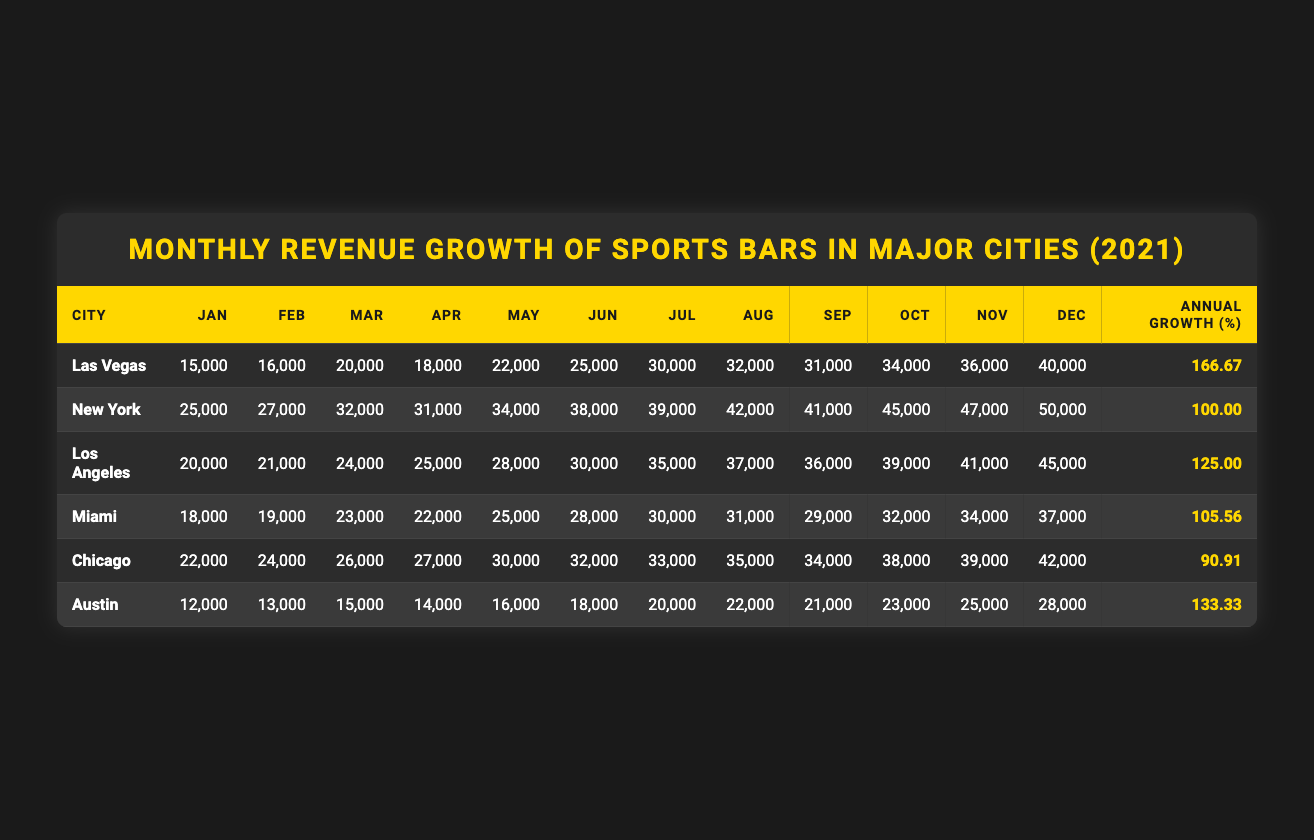What city had the highest monthly revenue in December? Looking at the December values, Las Vegas had 40,000, New York had 50,000, Los Angeles had 45,000, Miami had 37,000, Chicago had 42,000, and Austin had 28,000. New York's value is the highest at 50,000.
Answer: New York Which city experienced the lowest annual growth percentage? The annual growth percentages for each city are: Las Vegas 166.67, New York 100.00, Los Angeles 125.00, Miami 105.56, Chicago 90.91, and Austin 133.33. Chicago has the lowest growth percentage at 90.91.
Answer: Chicago What is the total revenue for Miami in the first half of the year (January to June)? The January to June revenues for Miami are: 18,000 (Jan) + 19,000 (Feb) + 23,000 (Mar) + 22,000 (Apr) + 25,000 (May) + 28,000 (Jun). Adding these values gives 18,000 + 19,000 + 23,000 + 22,000 + 25,000 + 28,000 = 135,000.
Answer: 135,000 In which month did Las Vegas see the revenue exceed 30,000 for the first time? Checking the monthly values for Las Vegas: January 15,000, February 16,000, March 20,000, April 18,000, May 22,000, June 25,000, July 30,000, and August 32,000. The first month exceeding 30,000 is August.
Answer: August What was the average monthly revenue for Los Angeles in 2021? For Los Angeles, the monthly revenues are: 20,000, 21,000, 24,000, 25,000, 28,000, 30,000, 35,000, 37,000, 36,000, 39,000, 41,000, and 45,000. The sum is 20,000 + 21,000 + 24,000 + 25,000 + 28,000 + 30,000 + 35,000 + 37,000 + 36,000 + 39,000 + 41,000 + 45,000 =  408,000. Dividing by 12 gives 408,000 / 12 = 34,000.
Answer: 34,000 Which city had a growth percentage of over 150%? The annual growth percentages are: Las Vegas 166.67, New York 100.00, Los Angeles 125.00, Miami 105.56, Chicago 90.91, and Austin 133.33. Only Las Vegas exceeds 150%.
Answer: Las Vegas If you combined the revenues of Chicago and Austin in October, how much would that be? Chicago's October revenue is 38,000 and Austin's is 23,000. Adding these values gives 38,000 + 23,000 = 61,000.
Answer: 61,000 How many cities showed an annual growth percentage greater than 100%? The cities with growth percentages are: Las Vegas 166.67, New York 100.00, Los Angeles 125.00, Miami 105.56, Chicago 90.91, and Austin 133.33. The cities exceeding 100% are Las Vegas, Los Angeles, Miami, and Austin, totaling four cities.
Answer: Four cities What was the revenue for NYC in March? New York's revenue in March is listed as 32,000 in the table.
Answer: 32,000 In the comparison between Miami and Las Vegas in July, who had more revenue? For July, Miami's revenue is 30,000 while Las Vegas's revenue is 30,000 as well. Since both values are the same, neither city had more revenue.
Answer: Neither city What is the difference in annual growth percentage between the highest and lowest cities? The highest annual growth percentage is 166.67 (Las Vegas) and the lowest is 90.91 (Chicago). The difference is 166.67 - 90.91 = 75.76.
Answer: 75.76 